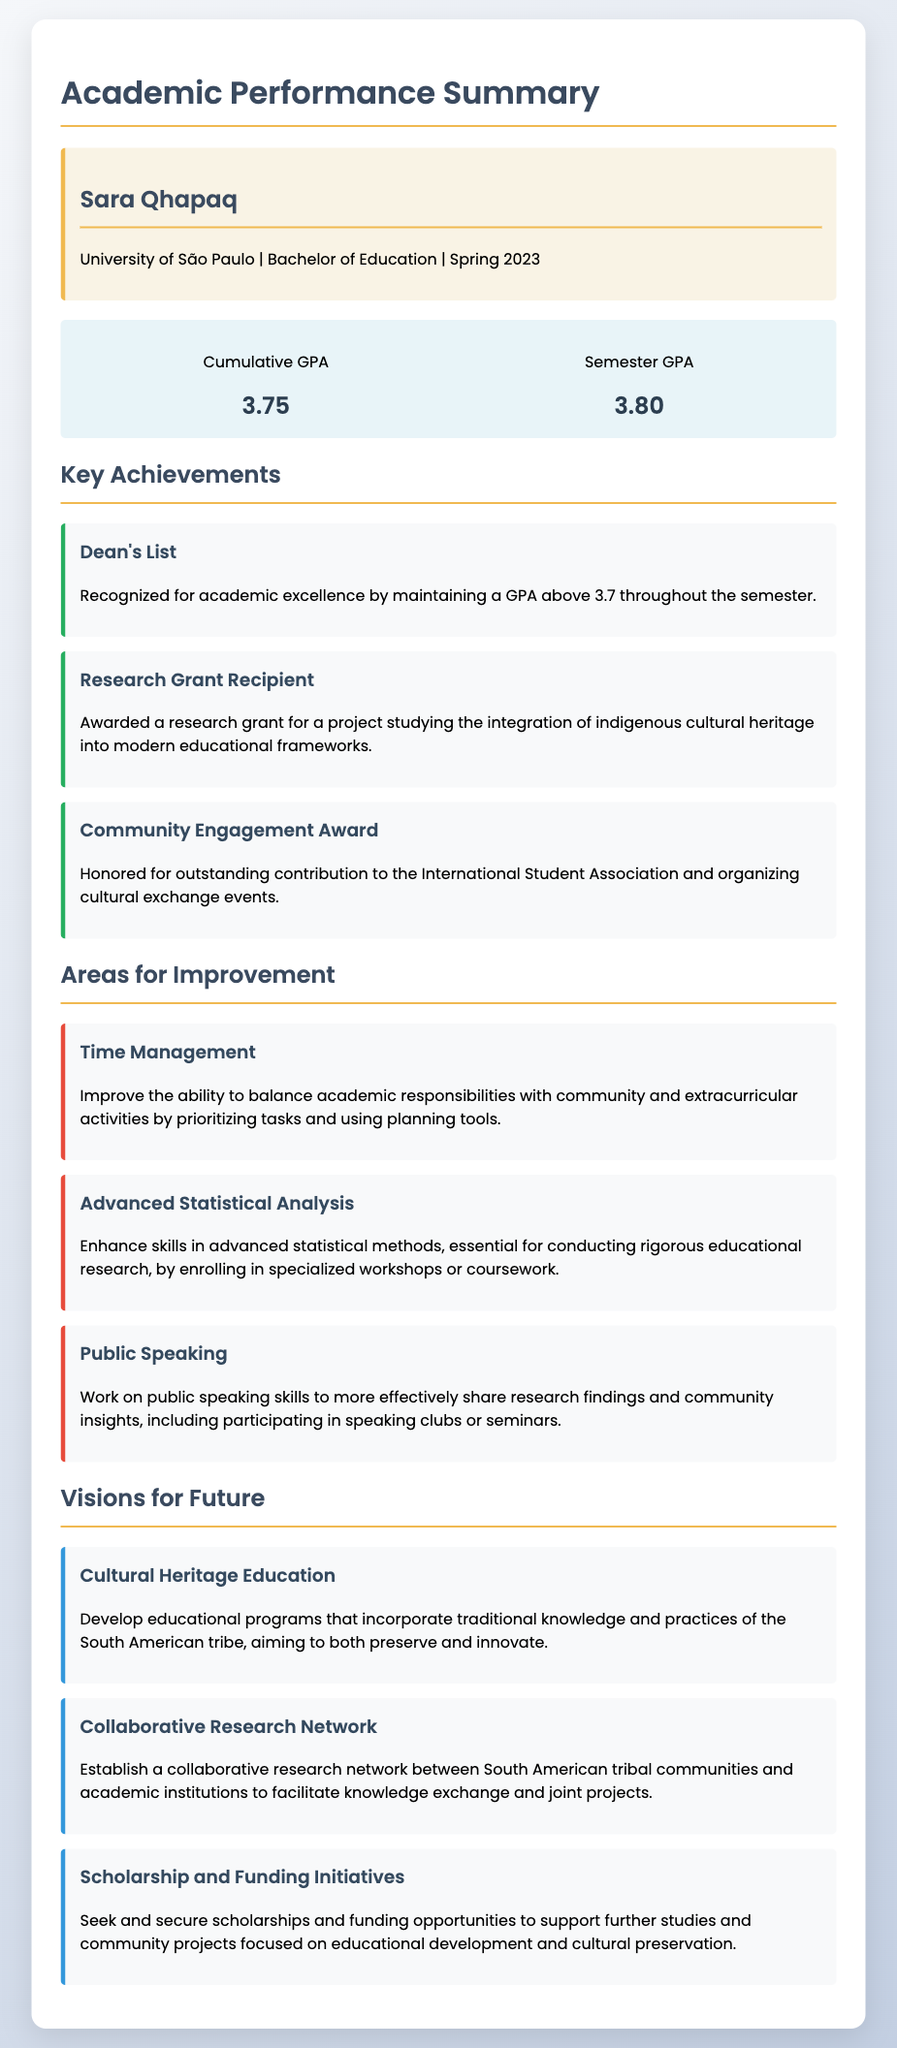What is Sara Qhapaq's cumulative GPA? The cumulative GPA is directly stated in the document as 3.75.
Answer: 3.75 What was Sara Qhapaq's semester GPA? The semester GPA is mentioned in the document as 3.80.
Answer: 3.80 Which award did Sara receive for academic excellence? The document specifies that she was recognized as being on the Dean's List for maintaining a GPA above 3.7.
Answer: Dean's List What is one of the key achievements related to research? The document highlights that Sara was awarded a research grant for studying indigenous cultural heritage.
Answer: Research Grant Recipient What area does Sara need to improve in? One of the areas for improvement listed is time management.
Answer: Time Management What vision does Sara have for incorporating cultural heritage? She aims to develop educational programs that incorporate traditional knowledge and practices.
Answer: Cultural Heritage Education What is a common theme of the visions for the future outlined in the document? The visions focus on education and cultural preservation for the South American tribe.
Answer: Education and Cultural Preservation What recognition did Sara receive for her contribution to community engagement? The document states she received the Community Engagement Award for her contributions to the International Student Association.
Answer: Community Engagement Award 